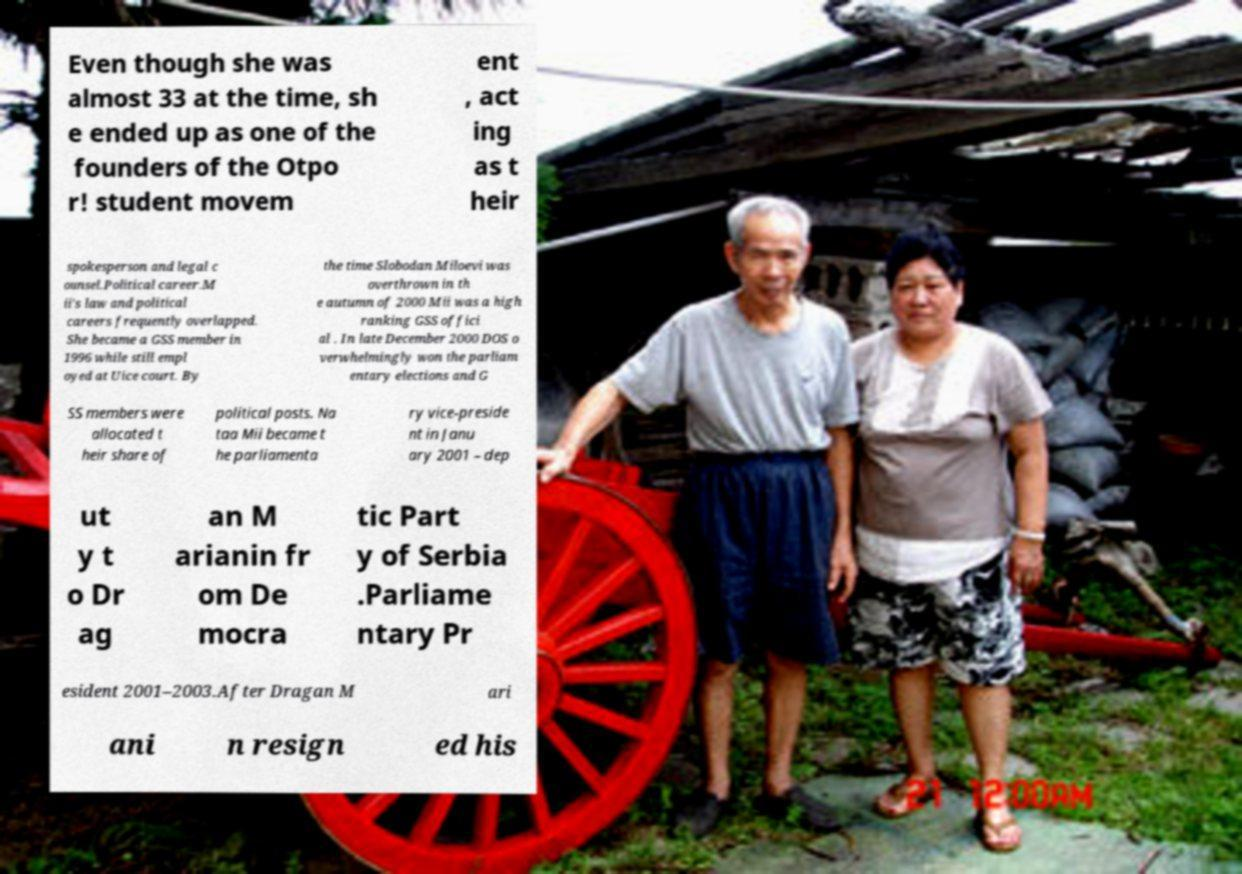Could you extract and type out the text from this image? Even though she was almost 33 at the time, sh e ended up as one of the founders of the Otpo r! student movem ent , act ing as t heir spokesperson and legal c ounsel.Political career.M ii's law and political careers frequently overlapped. She became a GSS member in 1996 while still empl oyed at Uice court. By the time Slobodan Miloevi was overthrown in th e autumn of 2000 Mii was a high ranking GSS offici al . In late December 2000 DOS o verwhelmingly won the parliam entary elections and G SS members were allocated t heir share of political posts. Na taa Mii became t he parliamenta ry vice-preside nt in Janu ary 2001 – dep ut y t o Dr ag an M arianin fr om De mocra tic Part y of Serbia .Parliame ntary Pr esident 2001–2003.After Dragan M ari ani n resign ed his 